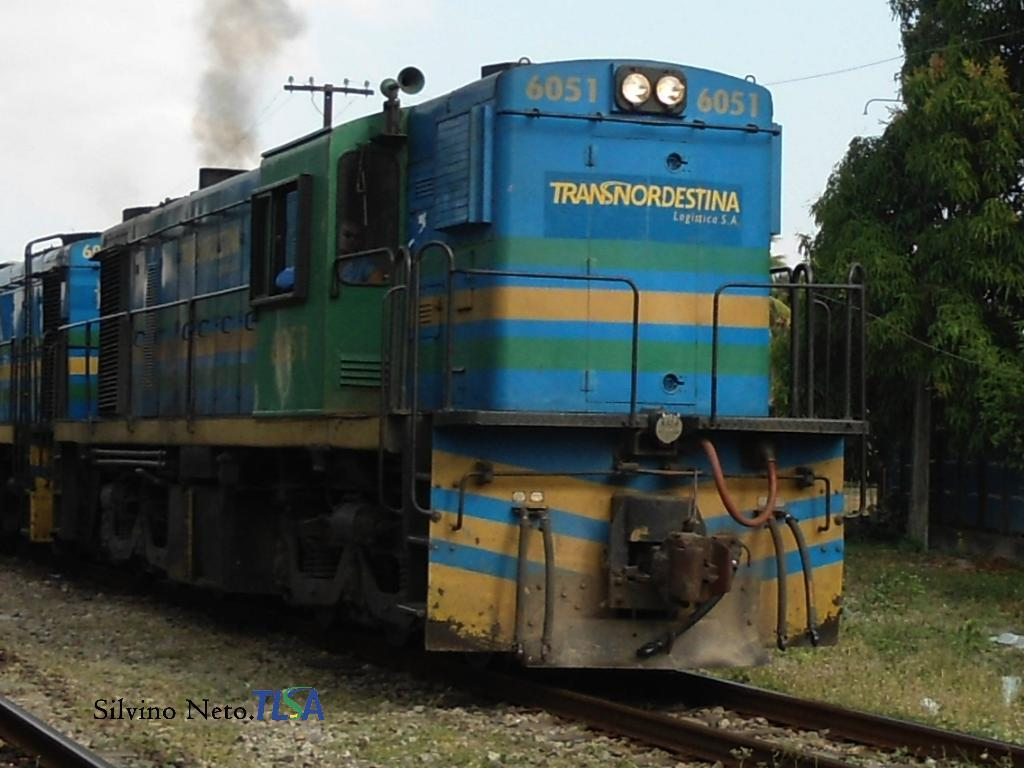What is the main subject of the image? The main subject of the image is a train. Where is the train located in the image? The train is on a track in the image. What can be seen in the background of the image? There are trees and sky visible in the background of the image. What is present in the bottom left corner of the image? There is text in the bottom left corner of the image. What is the train traveling on? The train is traveling on a track in the image. What is the aftermath of the mark on the sky in the image? There is no mark on the sky in the image, and therefore no aftermath can be observed. 